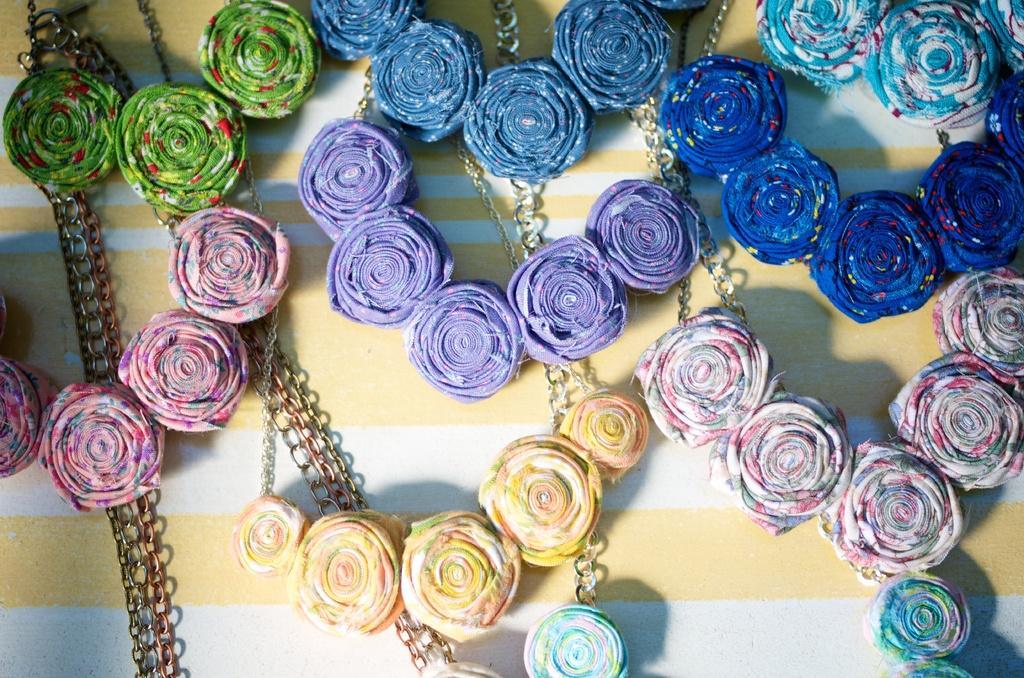Please provide a concise description of this image. Here in this picture we can see number of colorful handmade roses with cloth are present on the table over there and we can also see chains in between them over there. 